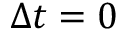<formula> <loc_0><loc_0><loc_500><loc_500>\Delta t = 0</formula> 